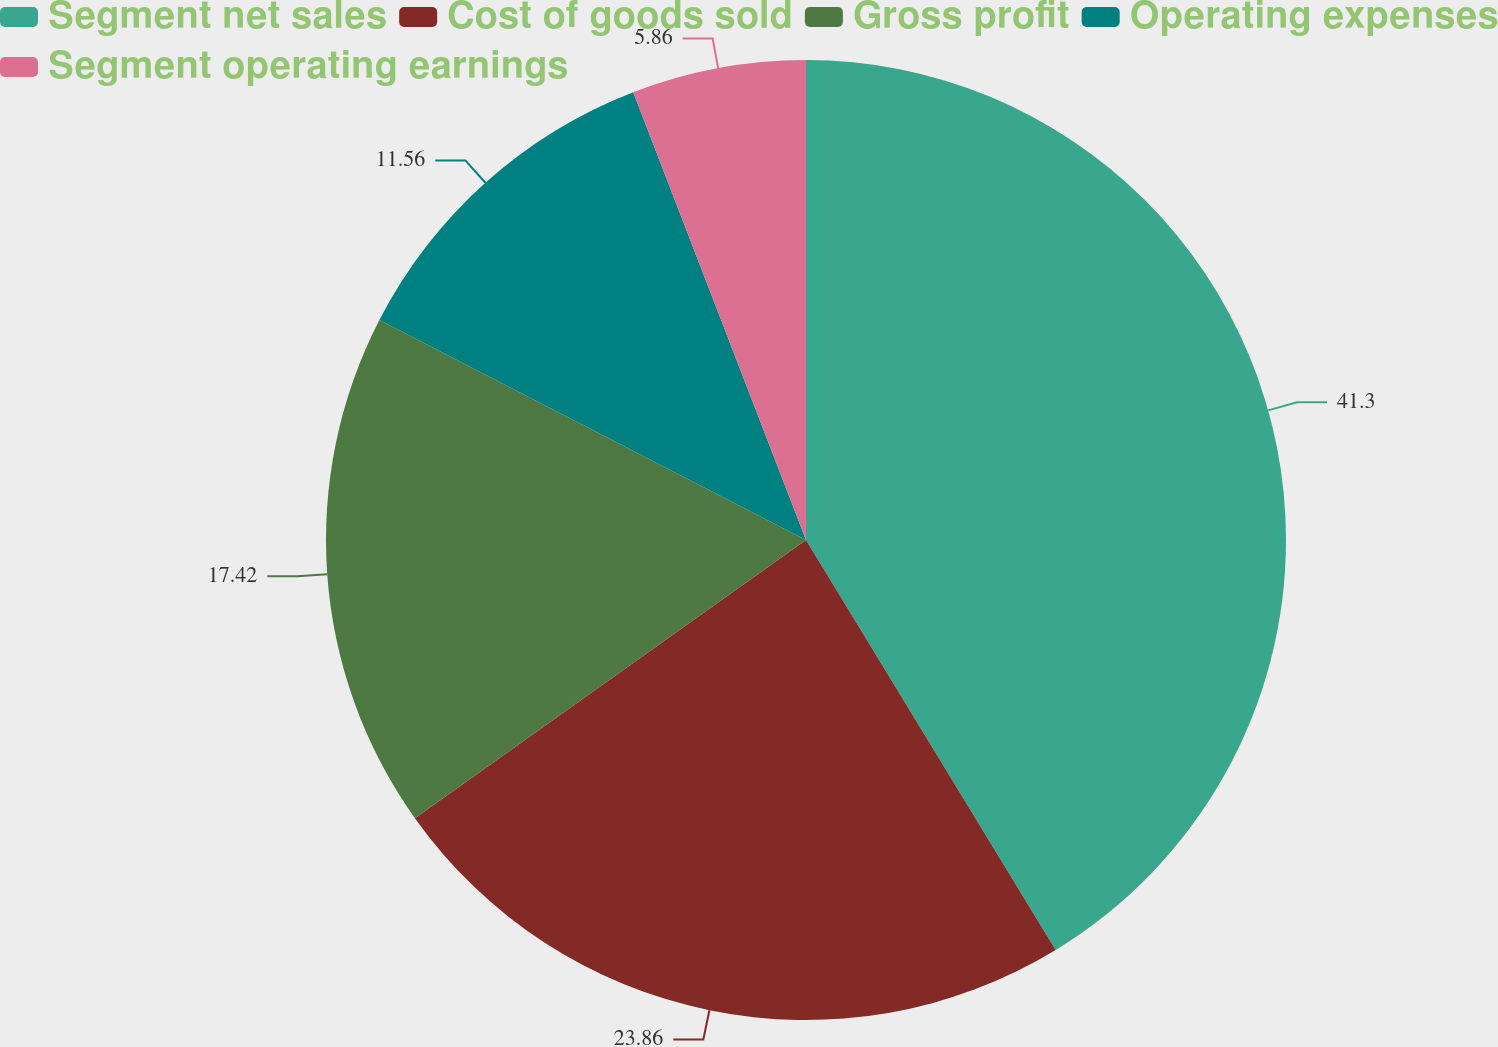<chart> <loc_0><loc_0><loc_500><loc_500><pie_chart><fcel>Segment net sales<fcel>Cost of goods sold<fcel>Gross profit<fcel>Operating expenses<fcel>Segment operating earnings<nl><fcel>41.29%<fcel>23.86%<fcel>17.42%<fcel>11.56%<fcel>5.86%<nl></chart> 